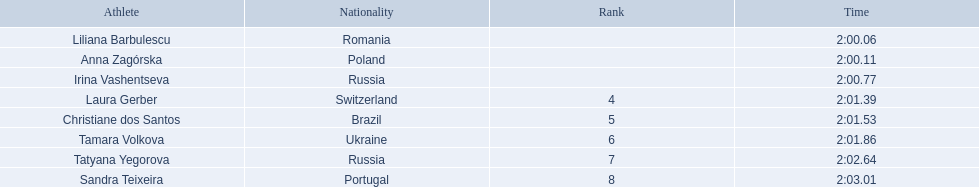What are the names of the competitors? Liliana Barbulescu, Anna Zagórska, Irina Vashentseva, Laura Gerber, Christiane dos Santos, Tamara Volkova, Tatyana Yegorova, Sandra Teixeira. Which finalist finished the fastest? Liliana Barbulescu. What athletes are in the top five for the women's 800 metres? Liliana Barbulescu, Anna Zagórska, Irina Vashentseva, Laura Gerber, Christiane dos Santos. Which athletes are in the top 3? Liliana Barbulescu, Anna Zagórska, Irina Vashentseva. Who is the second place runner in the women's 800 metres? Anna Zagórska. What is the second place runner's time? 2:00.11. 